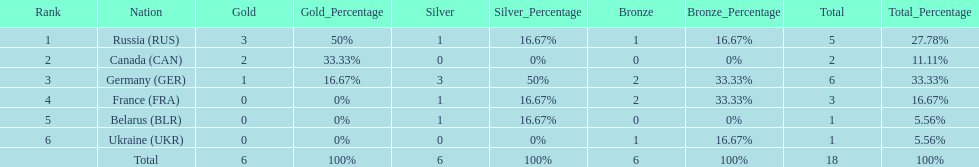What country had the most medals total at the the 1994 winter olympics biathlon? Germany (GER). 